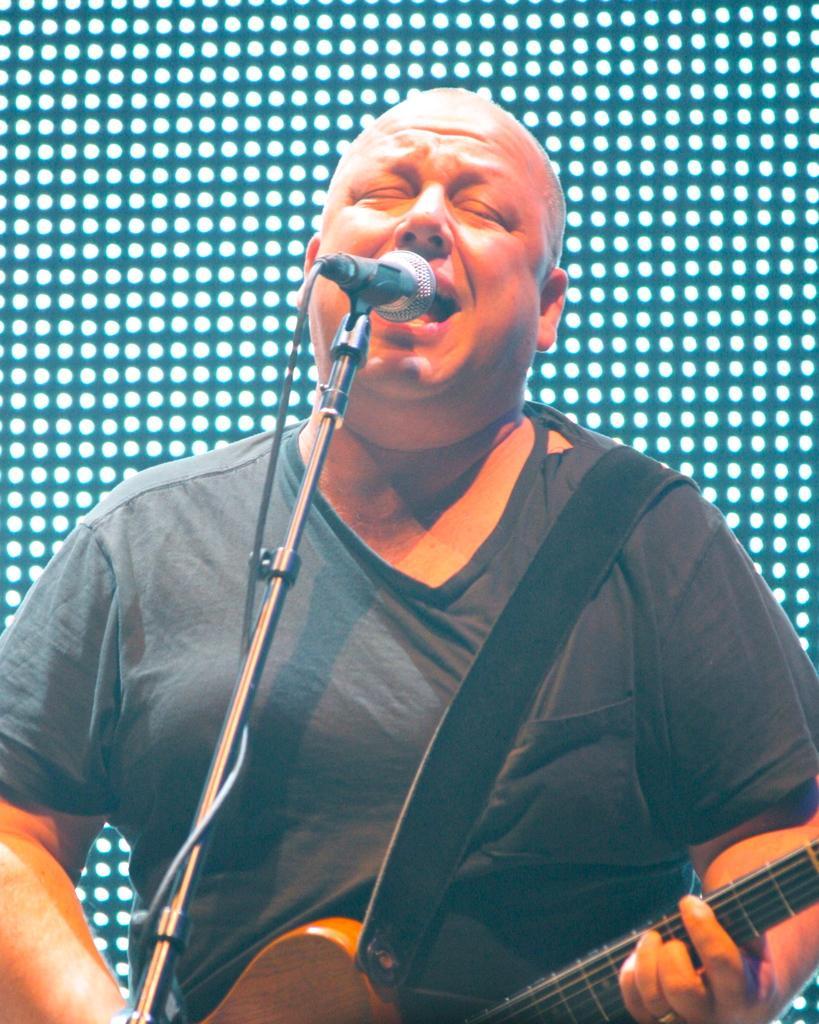Describe this image in one or two sentences. In this image i can see a man holding a guitar and singing there is a micro phone in front of a man. 